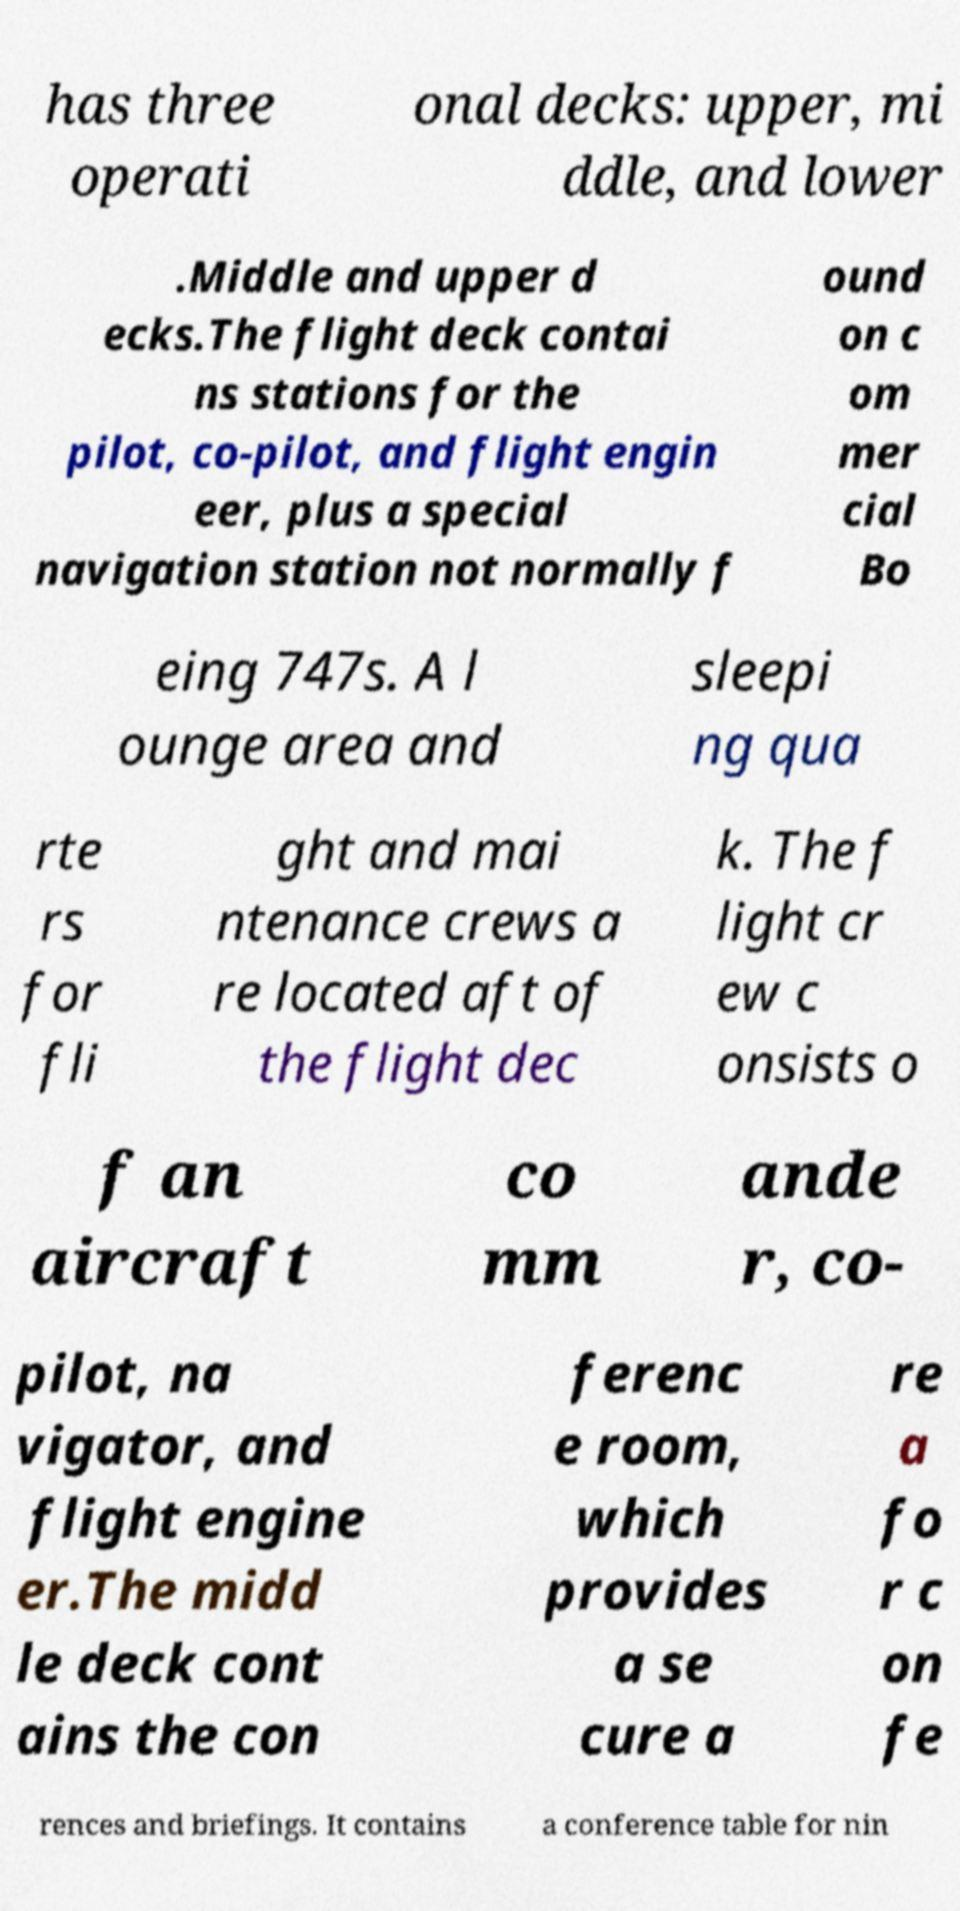Can you accurately transcribe the text from the provided image for me? has three operati onal decks: upper, mi ddle, and lower .Middle and upper d ecks.The flight deck contai ns stations for the pilot, co-pilot, and flight engin eer, plus a special navigation station not normally f ound on c om mer cial Bo eing 747s. A l ounge area and sleepi ng qua rte rs for fli ght and mai ntenance crews a re located aft of the flight dec k. The f light cr ew c onsists o f an aircraft co mm ande r, co- pilot, na vigator, and flight engine er.The midd le deck cont ains the con ferenc e room, which provides a se cure a re a fo r c on fe rences and briefings. It contains a conference table for nin 